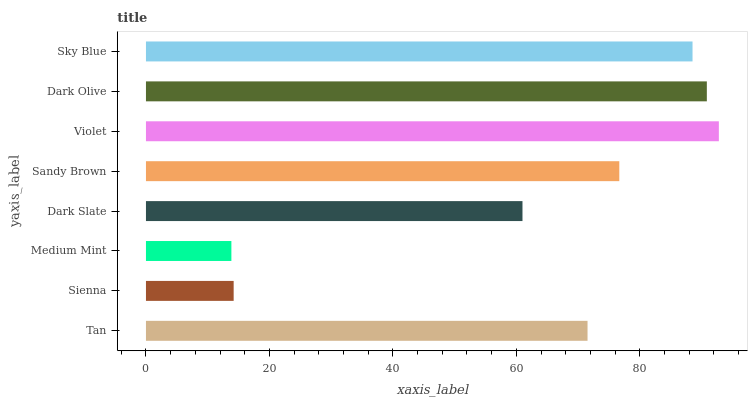Is Medium Mint the minimum?
Answer yes or no. Yes. Is Violet the maximum?
Answer yes or no. Yes. Is Sienna the minimum?
Answer yes or no. No. Is Sienna the maximum?
Answer yes or no. No. Is Tan greater than Sienna?
Answer yes or no. Yes. Is Sienna less than Tan?
Answer yes or no. Yes. Is Sienna greater than Tan?
Answer yes or no. No. Is Tan less than Sienna?
Answer yes or no. No. Is Sandy Brown the high median?
Answer yes or no. Yes. Is Tan the low median?
Answer yes or no. Yes. Is Sienna the high median?
Answer yes or no. No. Is Dark Olive the low median?
Answer yes or no. No. 